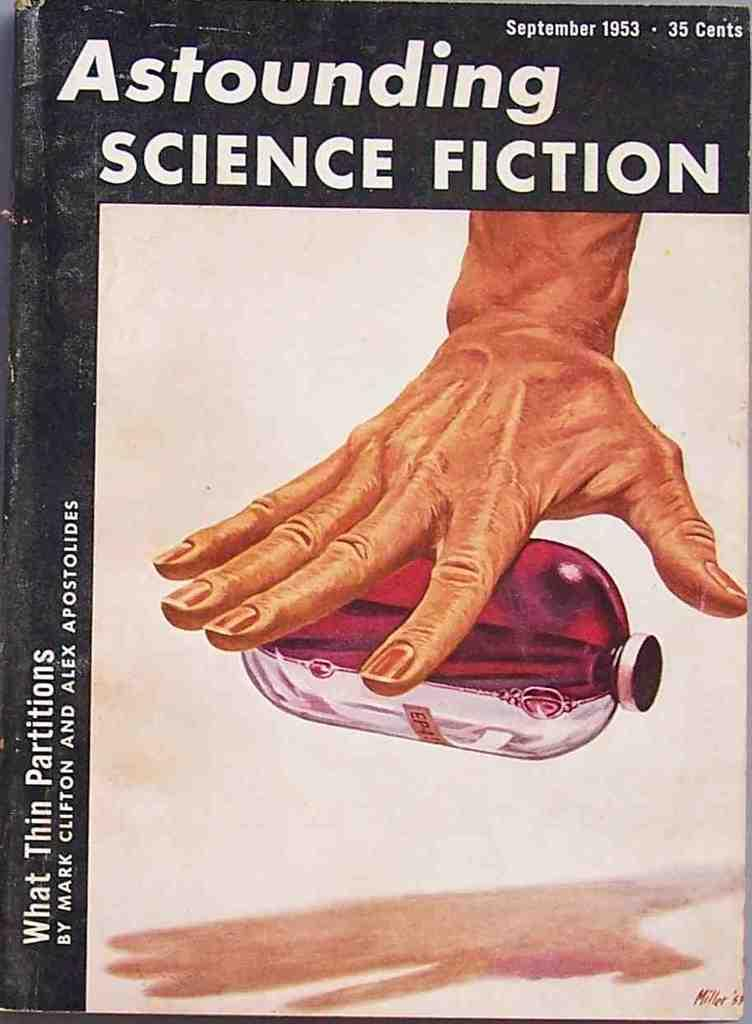<image>
Present a compact description of the photo's key features. A book dated September 1953 has a hand on the cover. 